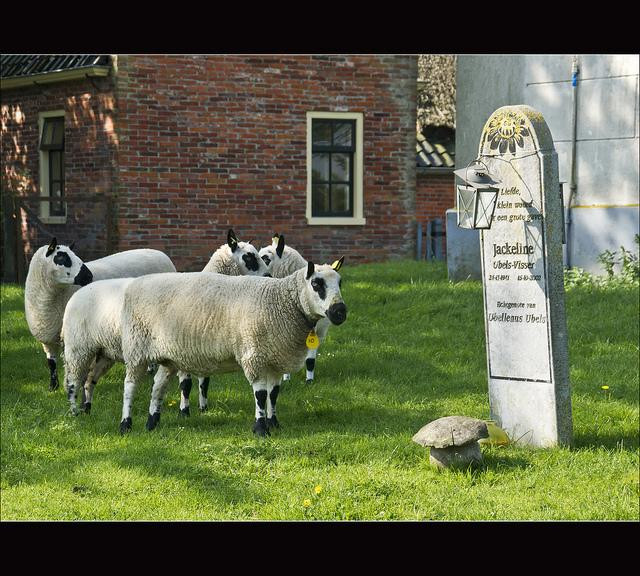What color are the patches around the eyes and noses of the sheep in this field? Please explain your reasoning. four. There are four patches. 